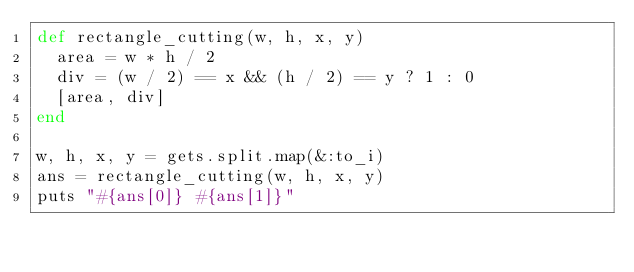Convert code to text. <code><loc_0><loc_0><loc_500><loc_500><_Ruby_>def rectangle_cutting(w, h, x, y)
  area = w * h / 2
  div = (w / 2) == x && (h / 2) == y ? 1 : 0
  [area, div]
end

w, h, x, y = gets.split.map(&:to_i)
ans = rectangle_cutting(w, h, x, y)
puts "#{ans[0]} #{ans[1]}"</code> 